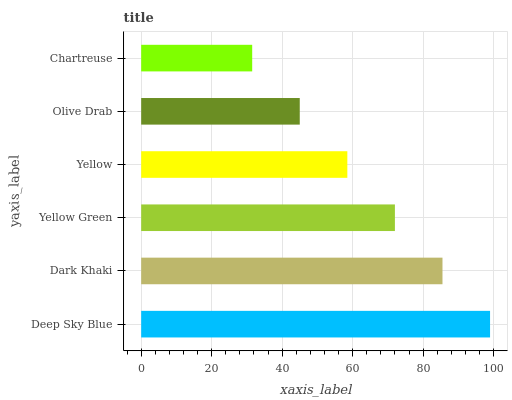Is Chartreuse the minimum?
Answer yes or no. Yes. Is Deep Sky Blue the maximum?
Answer yes or no. Yes. Is Dark Khaki the minimum?
Answer yes or no. No. Is Dark Khaki the maximum?
Answer yes or no. No. Is Deep Sky Blue greater than Dark Khaki?
Answer yes or no. Yes. Is Dark Khaki less than Deep Sky Blue?
Answer yes or no. Yes. Is Dark Khaki greater than Deep Sky Blue?
Answer yes or no. No. Is Deep Sky Blue less than Dark Khaki?
Answer yes or no. No. Is Yellow Green the high median?
Answer yes or no. Yes. Is Yellow the low median?
Answer yes or no. Yes. Is Dark Khaki the high median?
Answer yes or no. No. Is Deep Sky Blue the low median?
Answer yes or no. No. 